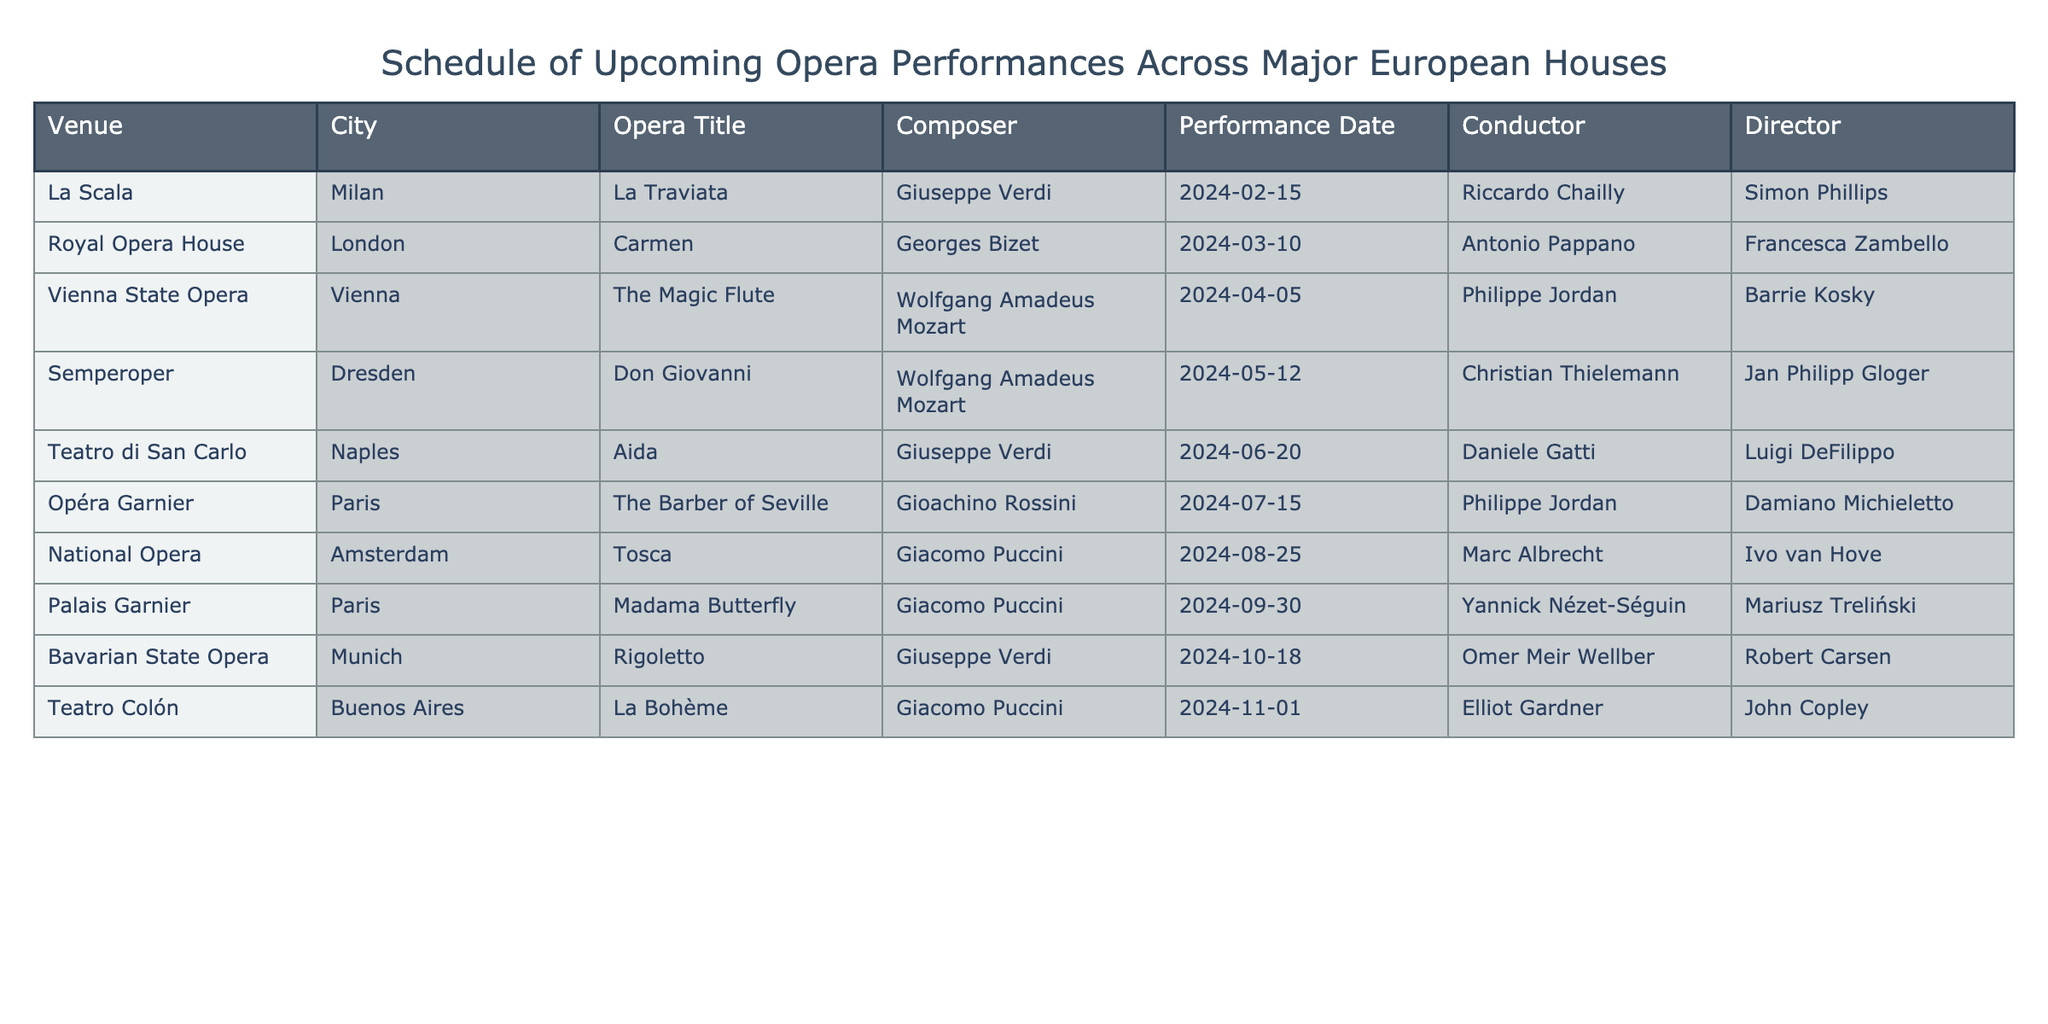What is the title of the opera being performed at La Scala in Milan? The table clearly states each venue along with the opera titles. Checking the row for La Scala, I see that the opera title is "La Traviata."
Answer: La Traviata Who is the conductor for "Carmen" at the Royal Opera House in London? Looking at the row for the Royal Opera House, I find the conductor listed as Antonio Pappano for the performance of "Carmen."
Answer: Antonio Pappano Which opera has the latest performance date? To find the latest performance date, I compare the performance dates across all rows. The latest date is "2024-11-01," which corresponds to "La Bohème" at Teatro Colón in Buenos Aires.
Answer: La Bohème Is "Madama Butterfly" being conducted by Riccardo Chailly? From the table, I check the row for "Madama Butterfly" at Palais Garnier, which shows the conductor is Yannick Nézet-Séguin. Riccardo Chailly is associated with La Scala, but not with "Madama Butterfly."
Answer: No How many operas are being performed by composer Giacomo Puccini? I go through the table and count the appearances of Giacomo Puccini. He is featured in two operas: "Tosca" at the National Opera and "Madama Butterfly" at Palais Garnier. Hence, the total is two.
Answer: 2 Which city will host the performance of "Aida"? By checking the specific row for "Aida," I see that the performance is scheduled at Teatro di San Carlo, which is located in Naples.
Answer: Naples What is the average number of days between the scheduled performances? First, I need to convert all performance dates into a standard date format and calculate the number of days between each consecutive performance. The differences between the performances (15 days, 20 days, 37 days, 35 days, 25 days, 36 days, 27 days, and 19 days) after finding the correct order and summing them yields a total of 199 days across 8 intervals. Dividing by 8 gives the average of about 24.875 days.
Answer: 24.88 Which venue is scheduled to host two operas composed by Giuseppe Verdi? Checking the list, I notice two performances by Giuseppe Verdi: "La Traviata" at La Scala and "Rigoletto" at the Bavarian State Opera. However, there's no single venue with both. Therefore, the answer is none.
Answer: None 